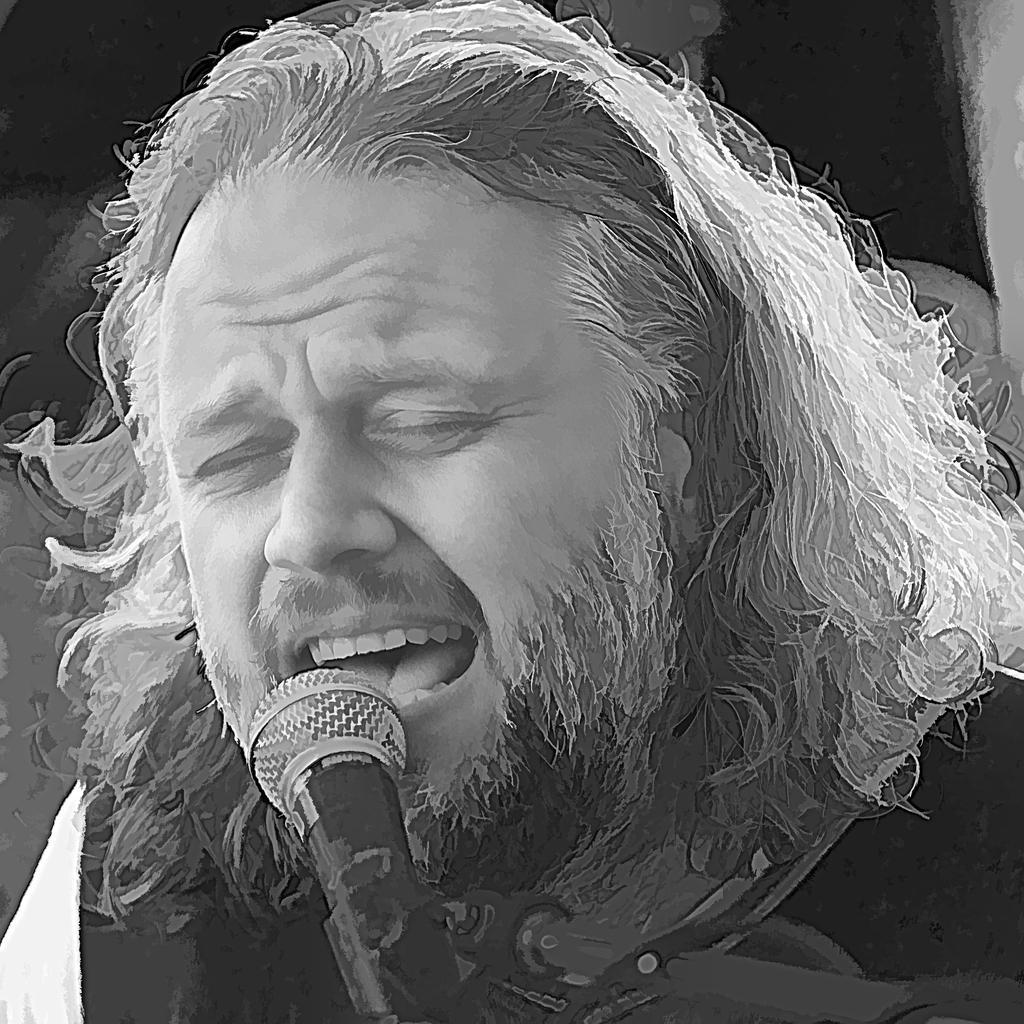Could you give a brief overview of what you see in this image? This is a black and white image. We can see a person and a microphone. 